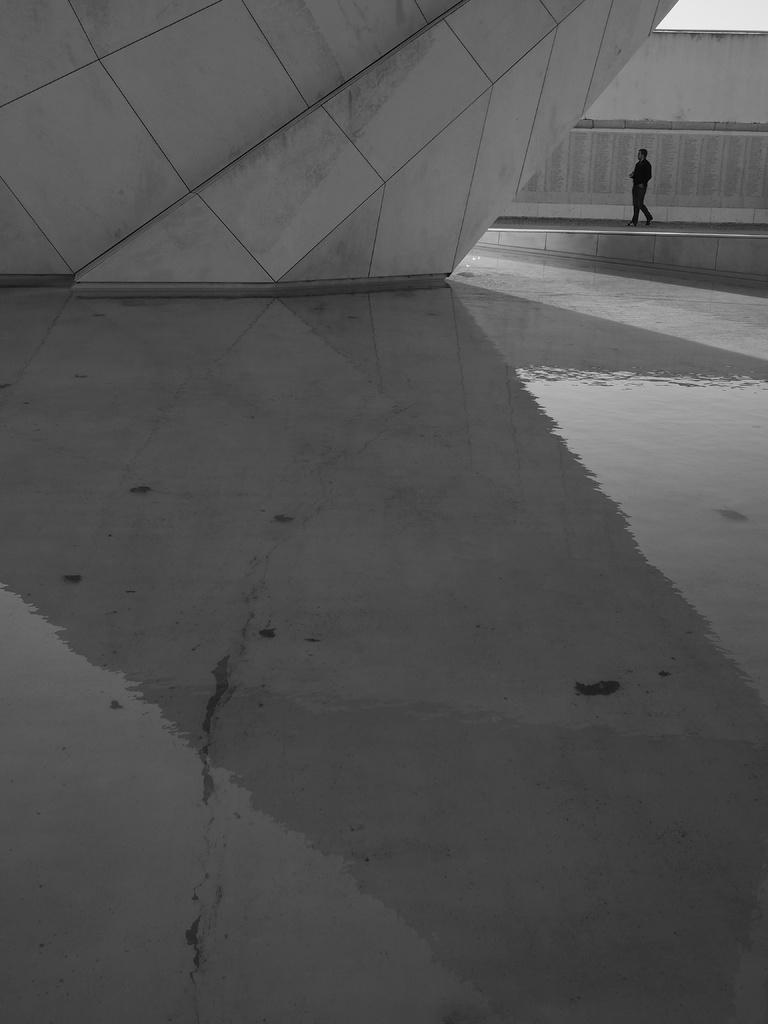In one or two sentences, can you explain what this image depicts? This image there is a person walking on the floor. Behind him there is a wall. There is some water on the floor. Top of image there is wall. 